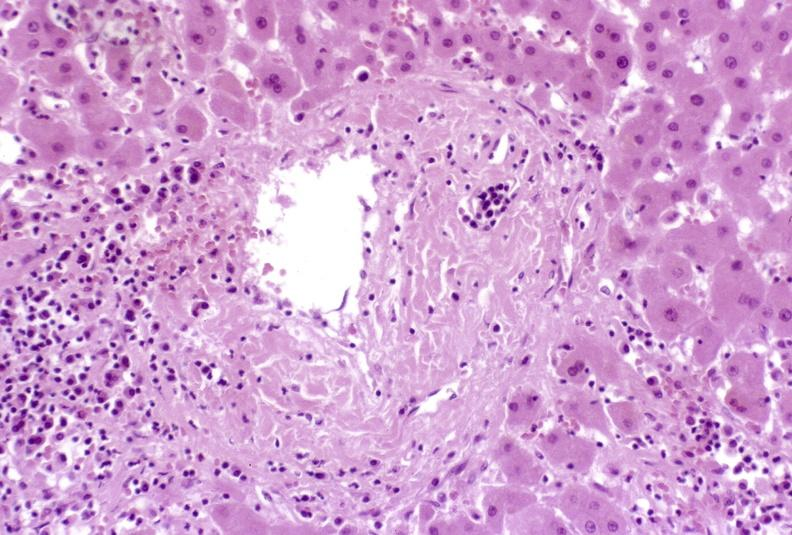does this image show severe acute rejection?
Answer the question using a single word or phrase. Yes 